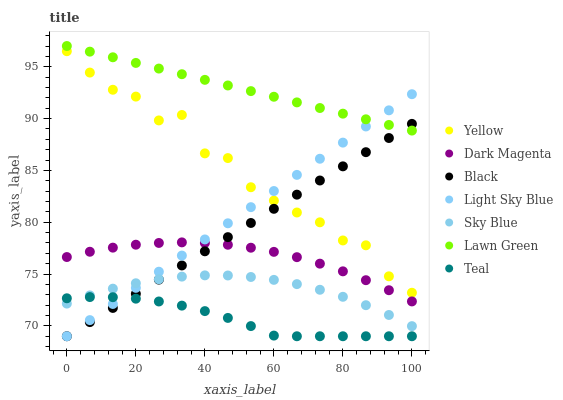Does Teal have the minimum area under the curve?
Answer yes or no. Yes. Does Lawn Green have the maximum area under the curve?
Answer yes or no. Yes. Does Dark Magenta have the minimum area under the curve?
Answer yes or no. No. Does Dark Magenta have the maximum area under the curve?
Answer yes or no. No. Is Light Sky Blue the smoothest?
Answer yes or no. Yes. Is Yellow the roughest?
Answer yes or no. Yes. Is Dark Magenta the smoothest?
Answer yes or no. No. Is Dark Magenta the roughest?
Answer yes or no. No. Does Light Sky Blue have the lowest value?
Answer yes or no. Yes. Does Dark Magenta have the lowest value?
Answer yes or no. No. Does Lawn Green have the highest value?
Answer yes or no. Yes. Does Dark Magenta have the highest value?
Answer yes or no. No. Is Yellow less than Lawn Green?
Answer yes or no. Yes. Is Lawn Green greater than Teal?
Answer yes or no. Yes. Does Sky Blue intersect Light Sky Blue?
Answer yes or no. Yes. Is Sky Blue less than Light Sky Blue?
Answer yes or no. No. Is Sky Blue greater than Light Sky Blue?
Answer yes or no. No. Does Yellow intersect Lawn Green?
Answer yes or no. No. 